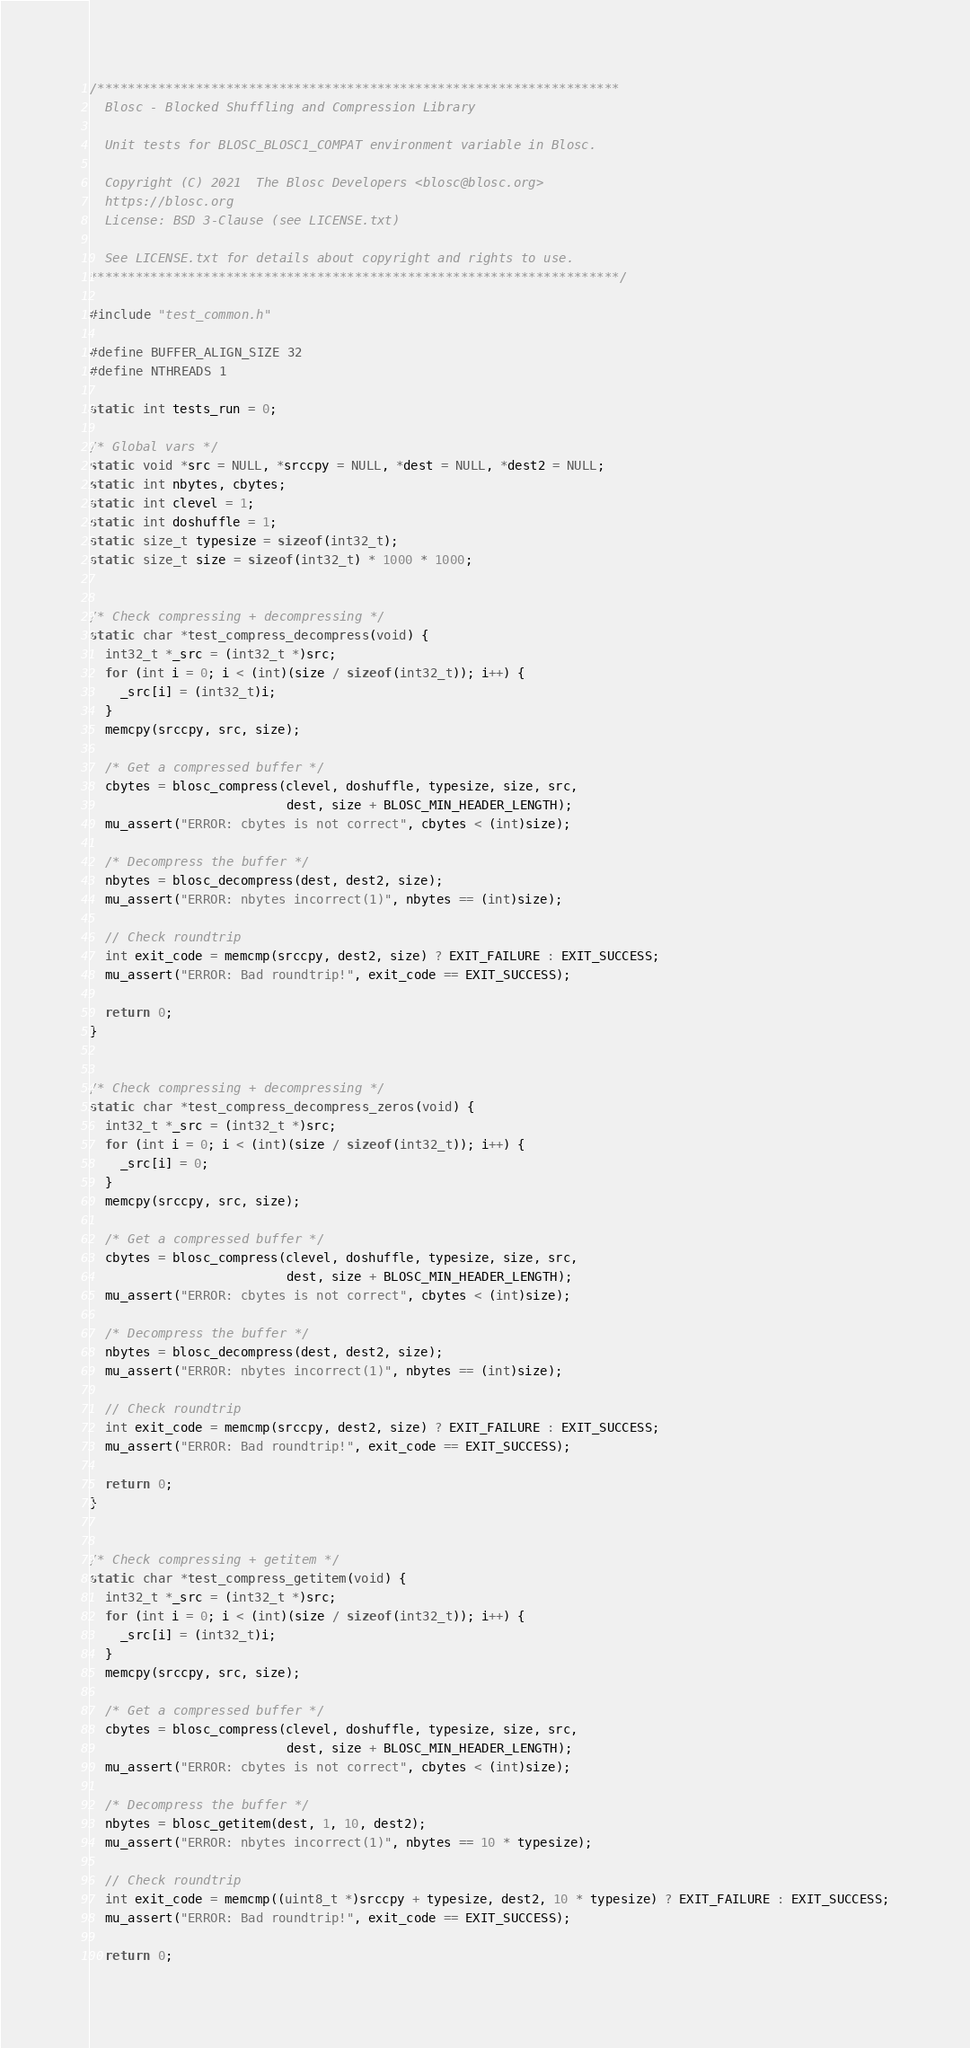<code> <loc_0><loc_0><loc_500><loc_500><_C_>/*********************************************************************
  Blosc - Blocked Shuffling and Compression Library

  Unit tests for BLOSC_BLOSC1_COMPAT environment variable in Blosc.

  Copyright (C) 2021  The Blosc Developers <blosc@blosc.org>
  https://blosc.org
  License: BSD 3-Clause (see LICENSE.txt)

  See LICENSE.txt for details about copyright and rights to use.
**********************************************************************/

#include "test_common.h"

#define BUFFER_ALIGN_SIZE 32
#define NTHREADS 1

static int tests_run = 0;

/* Global vars */
static void *src = NULL, *srccpy = NULL, *dest = NULL, *dest2 = NULL;
static int nbytes, cbytes;
static int clevel = 1;
static int doshuffle = 1;
static size_t typesize = sizeof(int32_t);
static size_t size = sizeof(int32_t) * 1000 * 1000;


/* Check compressing + decompressing */
static char *test_compress_decompress(void) {
  int32_t *_src = (int32_t *)src;
  for (int i = 0; i < (int)(size / sizeof(int32_t)); i++) {
    _src[i] = (int32_t)i;
  }
  memcpy(srccpy, src, size);

  /* Get a compressed buffer */
  cbytes = blosc_compress(clevel, doshuffle, typesize, size, src,
                          dest, size + BLOSC_MIN_HEADER_LENGTH);
  mu_assert("ERROR: cbytes is not correct", cbytes < (int)size);

  /* Decompress the buffer */
  nbytes = blosc_decompress(dest, dest2, size);
  mu_assert("ERROR: nbytes incorrect(1)", nbytes == (int)size);

  // Check roundtrip
  int exit_code = memcmp(srccpy, dest2, size) ? EXIT_FAILURE : EXIT_SUCCESS;
  mu_assert("ERROR: Bad roundtrip!", exit_code == EXIT_SUCCESS);

  return 0;
}


/* Check compressing + decompressing */
static char *test_compress_decompress_zeros(void) {
  int32_t *_src = (int32_t *)src;
  for (int i = 0; i < (int)(size / sizeof(int32_t)); i++) {
    _src[i] = 0;
  }
  memcpy(srccpy, src, size);

  /* Get a compressed buffer */
  cbytes = blosc_compress(clevel, doshuffle, typesize, size, src,
                          dest, size + BLOSC_MIN_HEADER_LENGTH);
  mu_assert("ERROR: cbytes is not correct", cbytes < (int)size);

  /* Decompress the buffer */
  nbytes = blosc_decompress(dest, dest2, size);
  mu_assert("ERROR: nbytes incorrect(1)", nbytes == (int)size);

  // Check roundtrip
  int exit_code = memcmp(srccpy, dest2, size) ? EXIT_FAILURE : EXIT_SUCCESS;
  mu_assert("ERROR: Bad roundtrip!", exit_code == EXIT_SUCCESS);

  return 0;
}


/* Check compressing + getitem */
static char *test_compress_getitem(void) {
  int32_t *_src = (int32_t *)src;
  for (int i = 0; i < (int)(size / sizeof(int32_t)); i++) {
    _src[i] = (int32_t)i;
  }
  memcpy(srccpy, src, size);

  /* Get a compressed buffer */
  cbytes = blosc_compress(clevel, doshuffle, typesize, size, src,
                          dest, size + BLOSC_MIN_HEADER_LENGTH);
  mu_assert("ERROR: cbytes is not correct", cbytes < (int)size);

  /* Decompress the buffer */
  nbytes = blosc_getitem(dest, 1, 10, dest2);
  mu_assert("ERROR: nbytes incorrect(1)", nbytes == 10 * typesize);

  // Check roundtrip
  int exit_code = memcmp((uint8_t *)srccpy + typesize, dest2, 10 * typesize) ? EXIT_FAILURE : EXIT_SUCCESS;
  mu_assert("ERROR: Bad roundtrip!", exit_code == EXIT_SUCCESS);

  return 0;</code> 